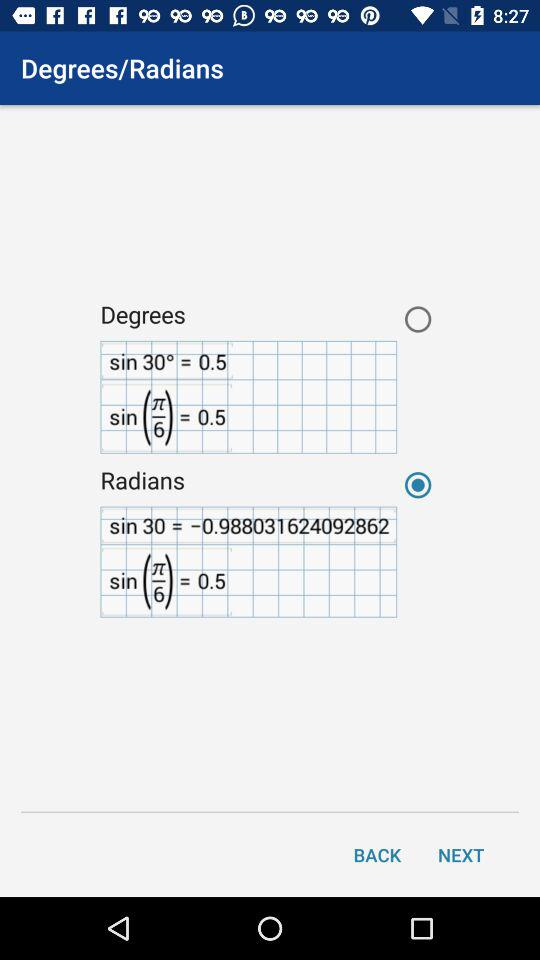Which option is selected? The selected option is "Radians". 